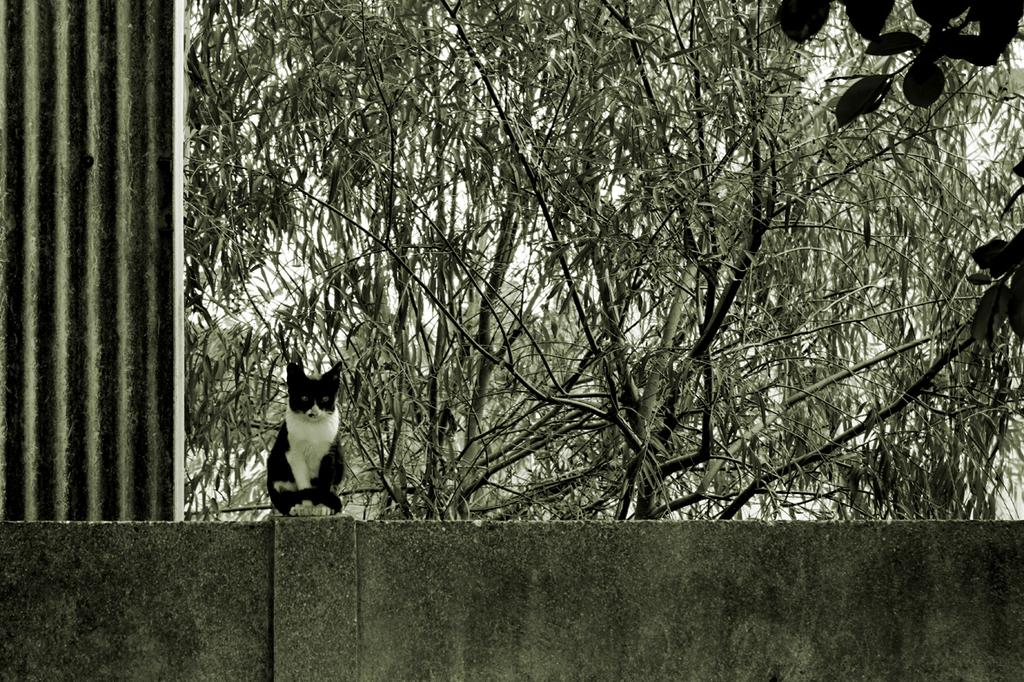What animal can be seen in the image? There is a cat in the image. Where is the cat located? The cat is sitting on a wall. What can be seen behind the wall in the image? There are trees visible behind the wall. What is the condition of the trees in the image? The trees have branches with leaves. What type of tax is being discussed in the image? There is no discussion of tax in the image; it features a cat sitting on a wall with trees in the background. 